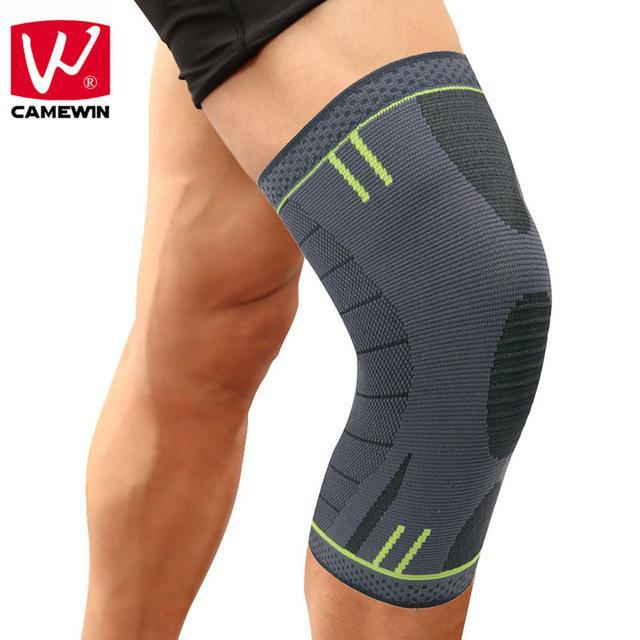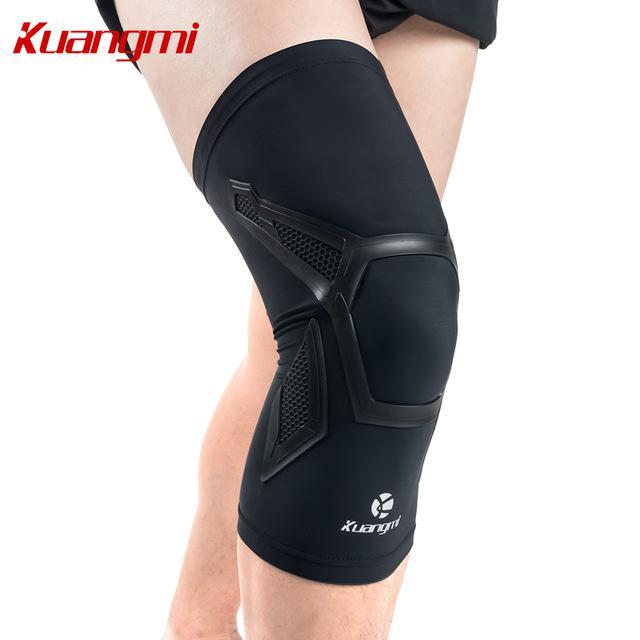The first image is the image on the left, the second image is the image on the right. Considering the images on both sides, is "The right image contains no more than one knee brace." valid? Answer yes or no. Yes. The first image is the image on the left, the second image is the image on the right. For the images displayed, is the sentence "There are exactly two knee braces." factually correct? Answer yes or no. Yes. 